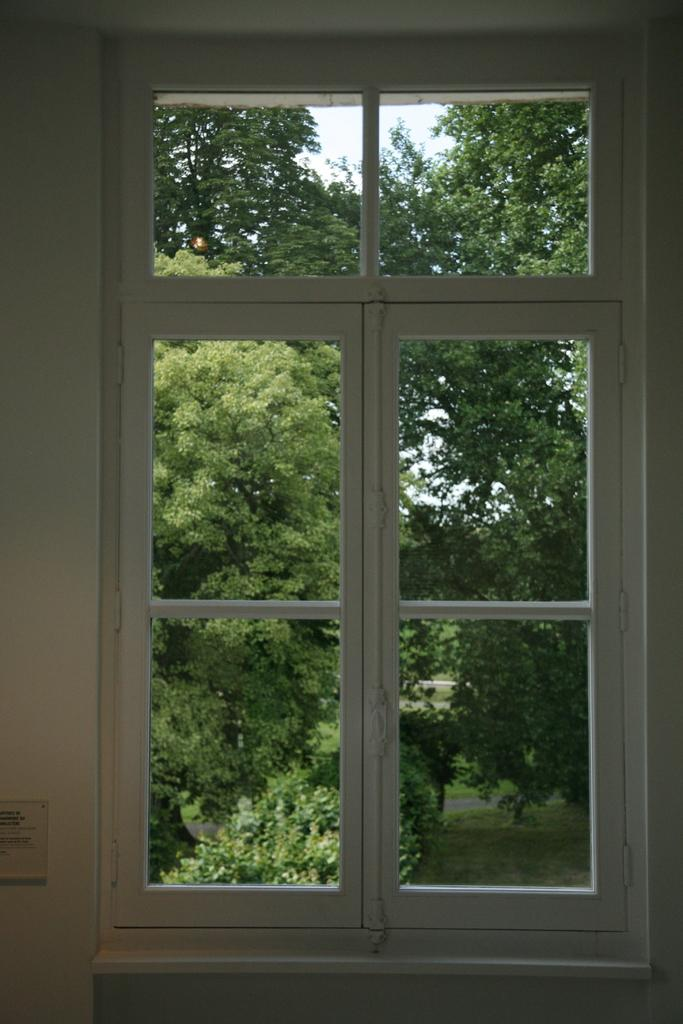What is present on a surface in the image? There is a window in the image. Where is the window located? The window is on a wall. What can be seen through the window? Trees are visible behind the window. Where are the trees located in relation to the window? The trees are on the land behind the window. What type of throne is visible in the image? There is no throne present in the image. 